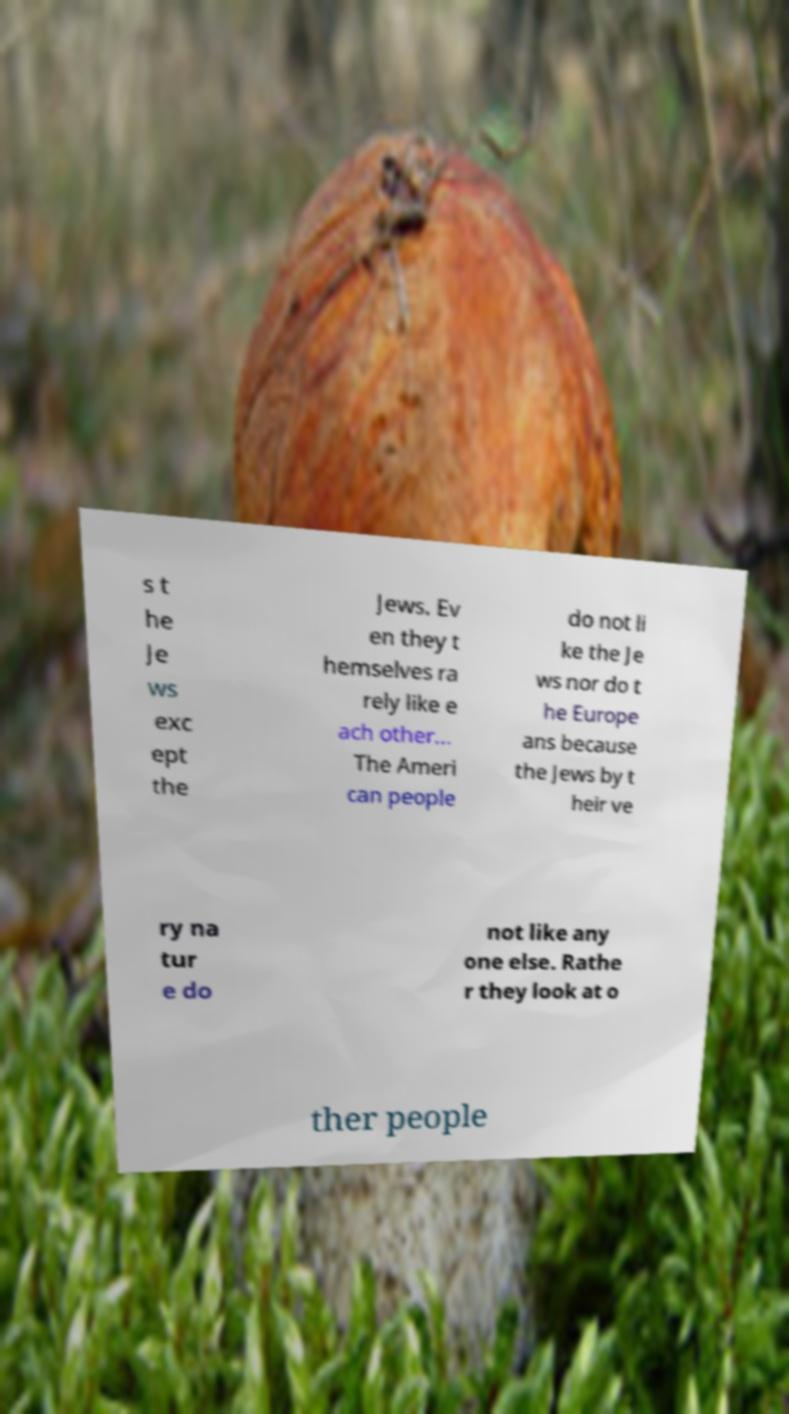Could you assist in decoding the text presented in this image and type it out clearly? s t he Je ws exc ept the Jews. Ev en they t hemselves ra rely like e ach other... The Ameri can people do not li ke the Je ws nor do t he Europe ans because the Jews by t heir ve ry na tur e do not like any one else. Rathe r they look at o ther people 